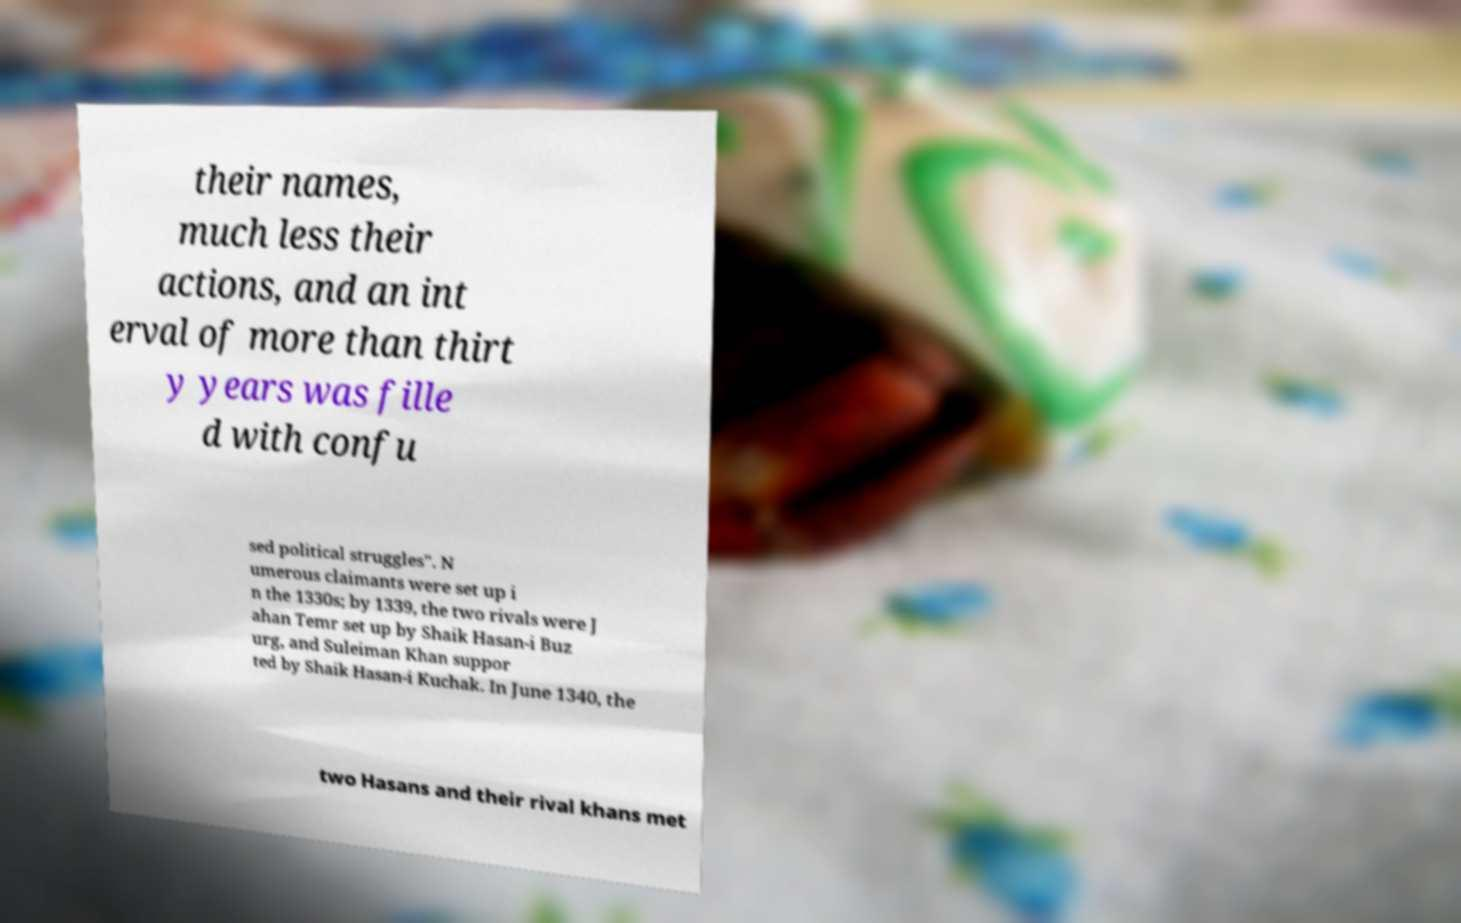Could you extract and type out the text from this image? their names, much less their actions, and an int erval of more than thirt y years was fille d with confu sed political struggles". N umerous claimants were set up i n the 1330s; by 1339, the two rivals were J ahan Temr set up by Shaik Hasan-i Buz urg, and Suleiman Khan suppor ted by Shaik Hasan-i Kuchak. In June 1340, the two Hasans and their rival khans met 